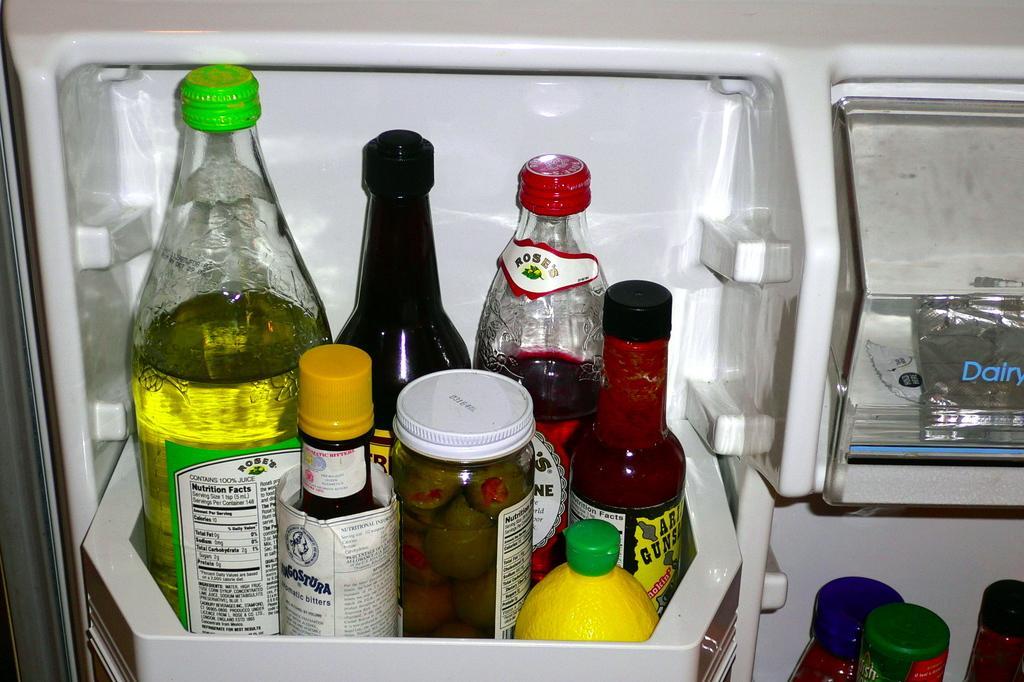Can you describe this image briefly? In this picture we can see bottles with stickers in rack of fridge or refrigerator. 